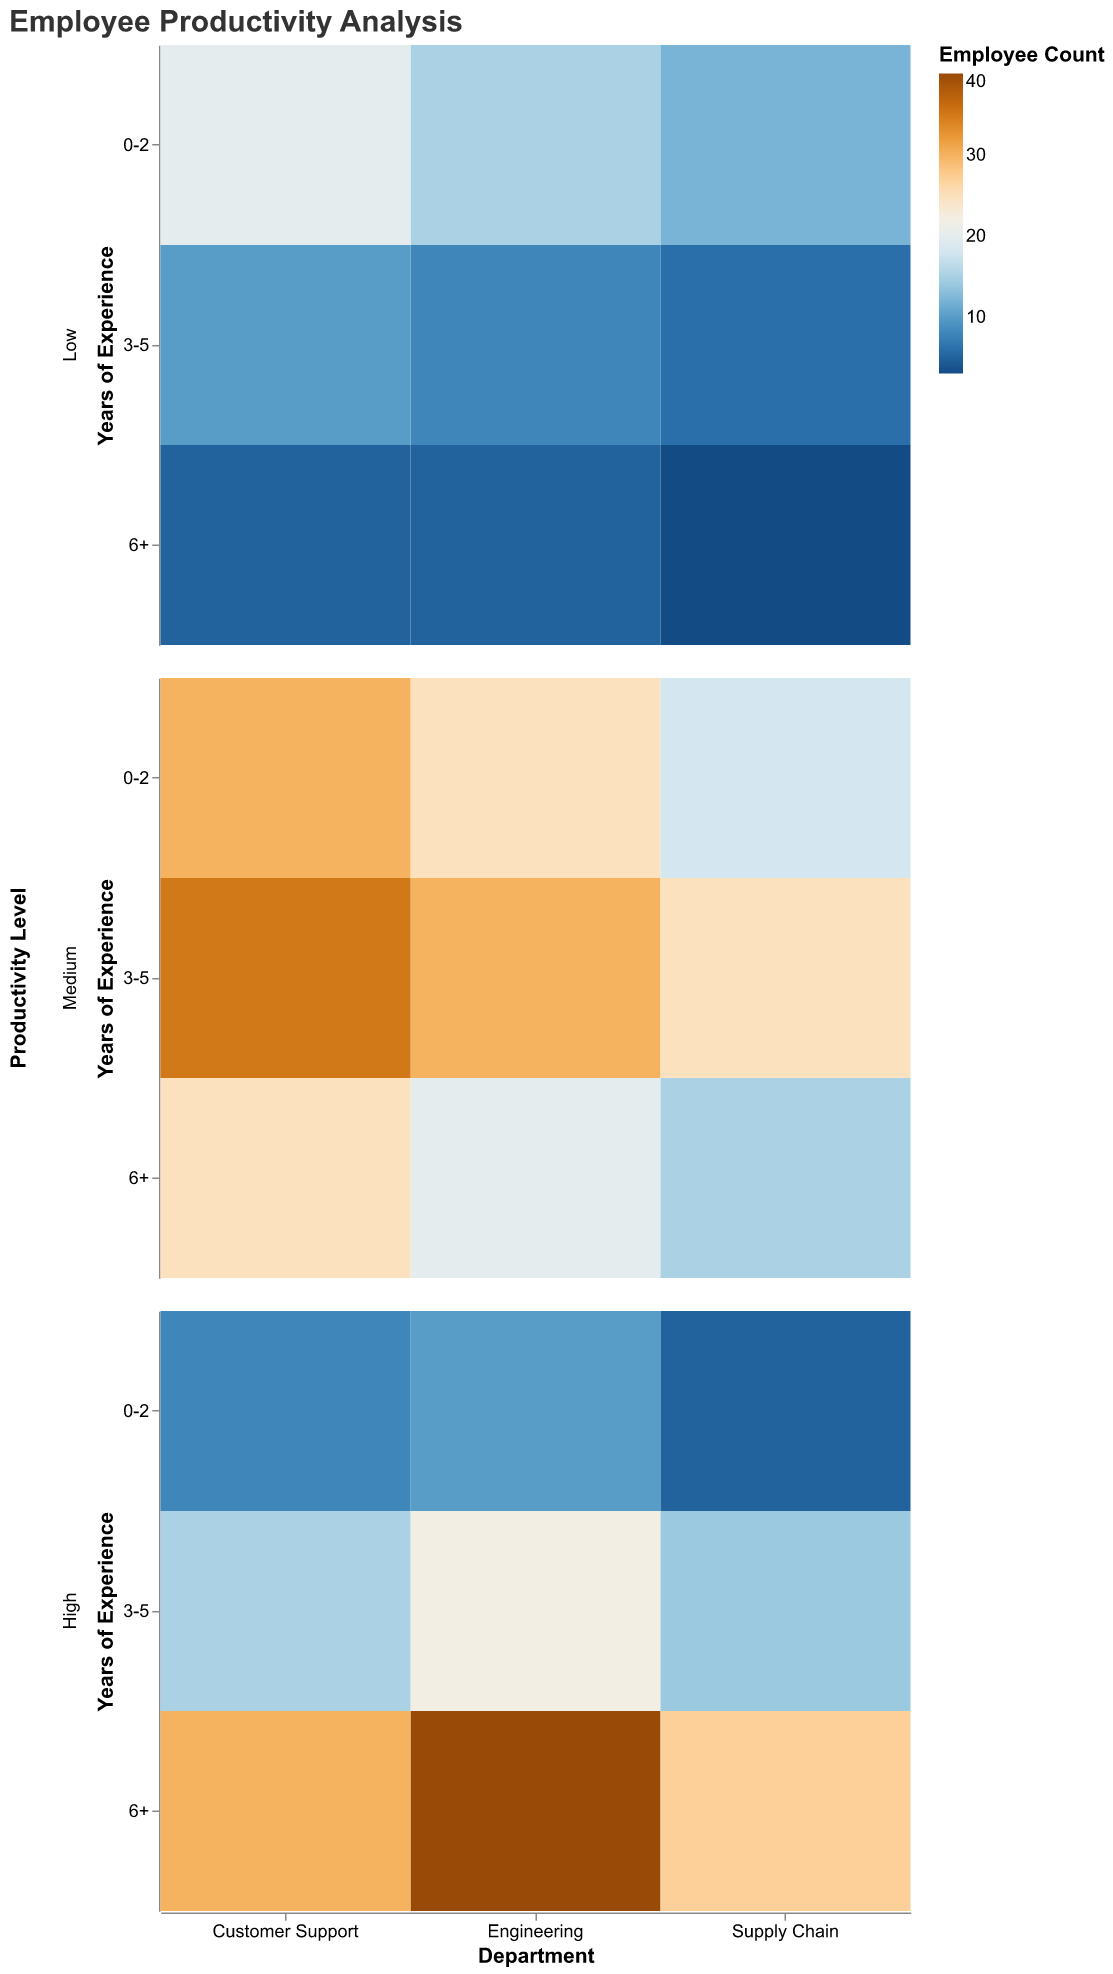What is the title of the plot? The title of the plot is displayed at the top and reads "Employee Productivity Analysis".
Answer: Employee Productivity Analysis Which department has the highest count of employees with high productivity in the 6+ years of experience category? By looking at the 6+ years of experience row under the High Productivity Level, we see the largest rectangle is in the Engineering column.
Answer: Engineering How many employees in the Supply Chain department have a medium productivity level and 3-5 years of experience? In the Supply Chain column, under the Medium Productivity Level, and in the 3-5 years of experience row, the count is clearly marked as 25.
Answer: 25 Which department has the least number of low productivity employees overall? To determine this, we need to sum the counts of low productivity employees across all experience years for each department. The totals are Engineering (15+8+5=28), Supply Chain (12+6+3=21), and Customer Support (20+10+5=35). Supply Chain has the least number.
Answer: Supply Chain In the Customer Support department, how does the count of employees with high productivity and 6+ years of experience compare to those with high productivity and 3-5 years of experience? In the Customer Support column, we see that for High Productivity Level, the count in the 6+ row is 30 and in the 3-5 row is 15. So, 6+ years high productivity count is twice that of 3-5 years.
Answer: 6+ years is double the 3-5 years What is the total count of employees with medium productivity and 0-2 years of experience across all departments? We need to sum the counts from the 0-2 years row under Medium Productivity Level for each department: Engineering (25), Supply Chain (18), and Customer Support (30). The total is 25+18+30=73.
Answer: 73 Which combination of department and years of experience shows the highest count of low productivity employees? We look for the largest rectangle in the Low Productivity Level rows across all departments. Customer Support, 0-2 years experience has the highest count of 20.
Answer: Customer Support, 0-2 years Is the count of high productivity employees with 3-5 years of experience higher in Supply Chain or Customer Support? Comparing the rectangles under High Productivity Level in the 3-5 years row for Supply Chain (14) and Customer Support (15), Customer Support has a higher count.
Answer: Customer Support How does the productivity level distribution differ between Engineering and Supply Chain for the 6+ years of experience category? For Engineering 6+ years: Low (5), Medium (20), High (40). For Supply Chain 6+ years: Low (3), Medium (15), High (27). Engineering has more employees in all productivity levels compared to Supply Chain.
Answer: Engineering has more employees in all productivity levels 